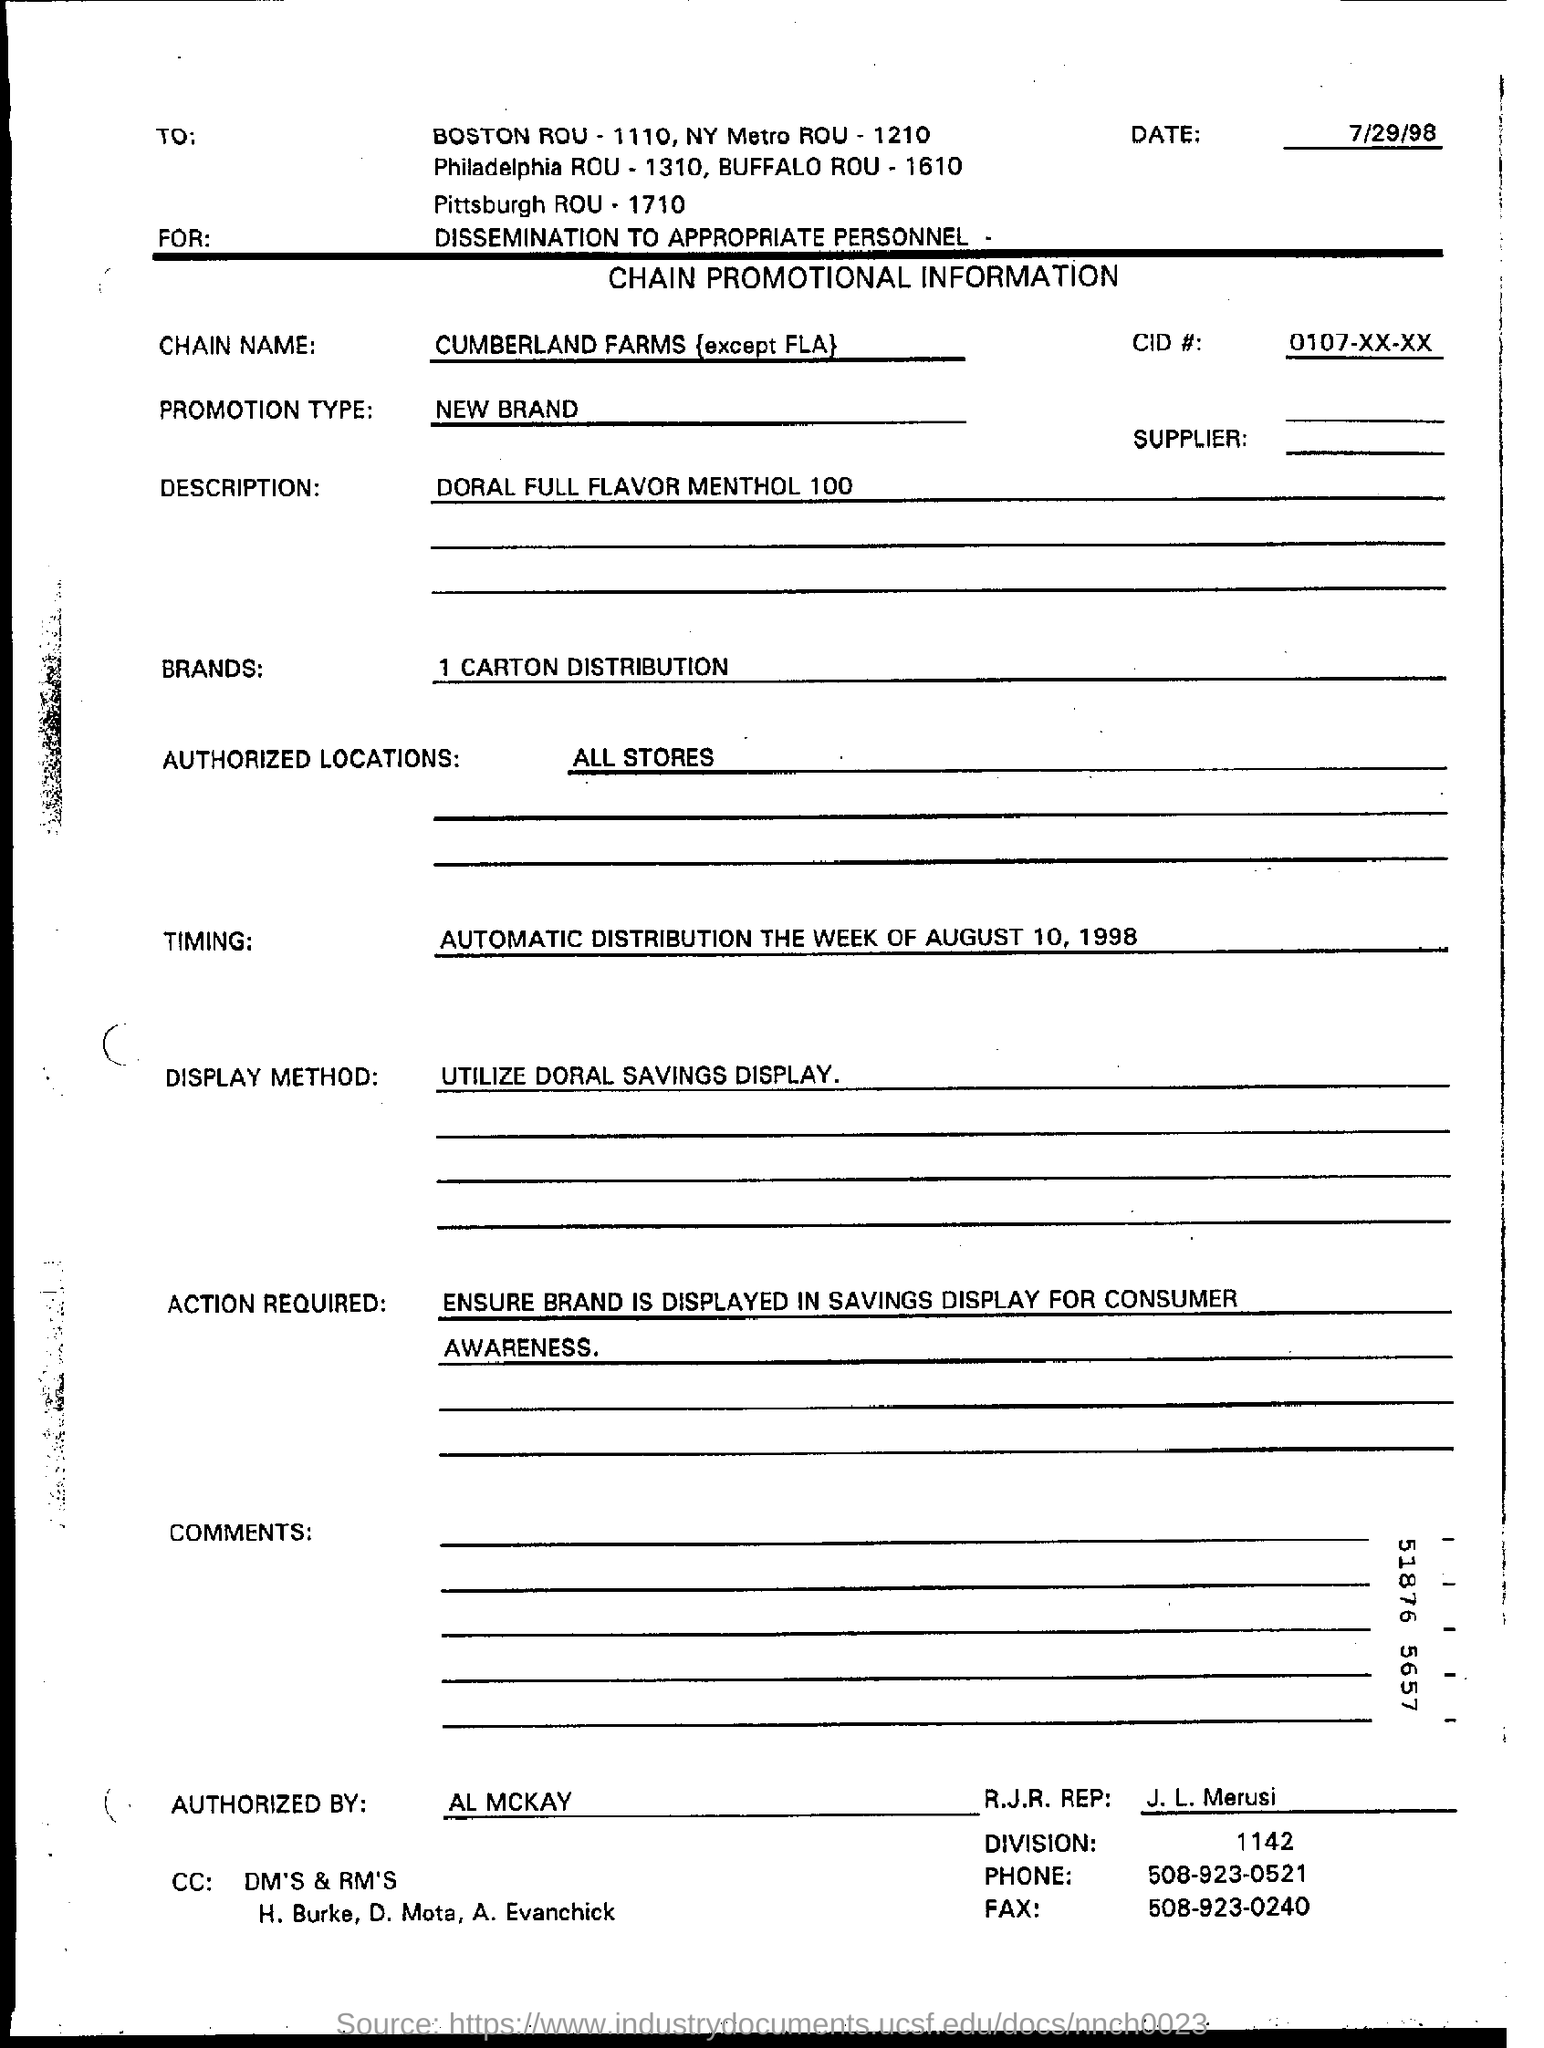When is the chain promotional information form dated?
Provide a succinct answer. 7/29/98. What are the authorized locations mentioned on the form?
Provide a short and direct response. ALL STORES. Who authorized the form?
Give a very brief answer. Al Mckay. 